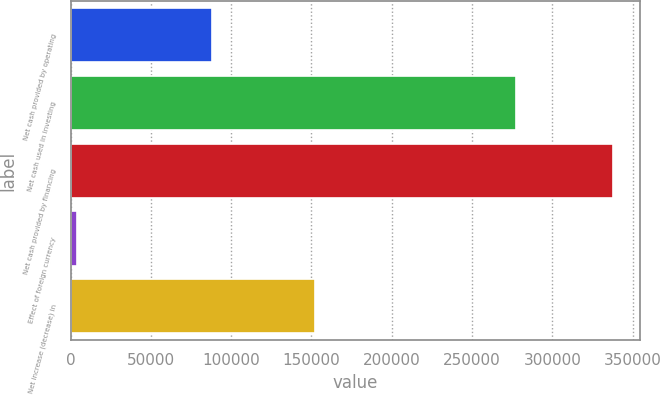Convert chart. <chart><loc_0><loc_0><loc_500><loc_500><bar_chart><fcel>Net cash provided by operating<fcel>Net cash used in investing<fcel>Net cash provided by financing<fcel>Effect of foreign currency<fcel>Net increase (decrease) in<nl><fcel>87882<fcel>277249<fcel>337672<fcel>3778<fcel>152083<nl></chart> 